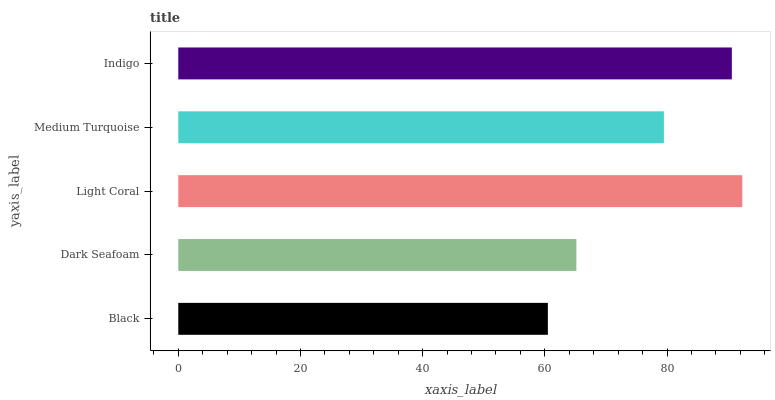Is Black the minimum?
Answer yes or no. Yes. Is Light Coral the maximum?
Answer yes or no. Yes. Is Dark Seafoam the minimum?
Answer yes or no. No. Is Dark Seafoam the maximum?
Answer yes or no. No. Is Dark Seafoam greater than Black?
Answer yes or no. Yes. Is Black less than Dark Seafoam?
Answer yes or no. Yes. Is Black greater than Dark Seafoam?
Answer yes or no. No. Is Dark Seafoam less than Black?
Answer yes or no. No. Is Medium Turquoise the high median?
Answer yes or no. Yes. Is Medium Turquoise the low median?
Answer yes or no. Yes. Is Dark Seafoam the high median?
Answer yes or no. No. Is Indigo the low median?
Answer yes or no. No. 